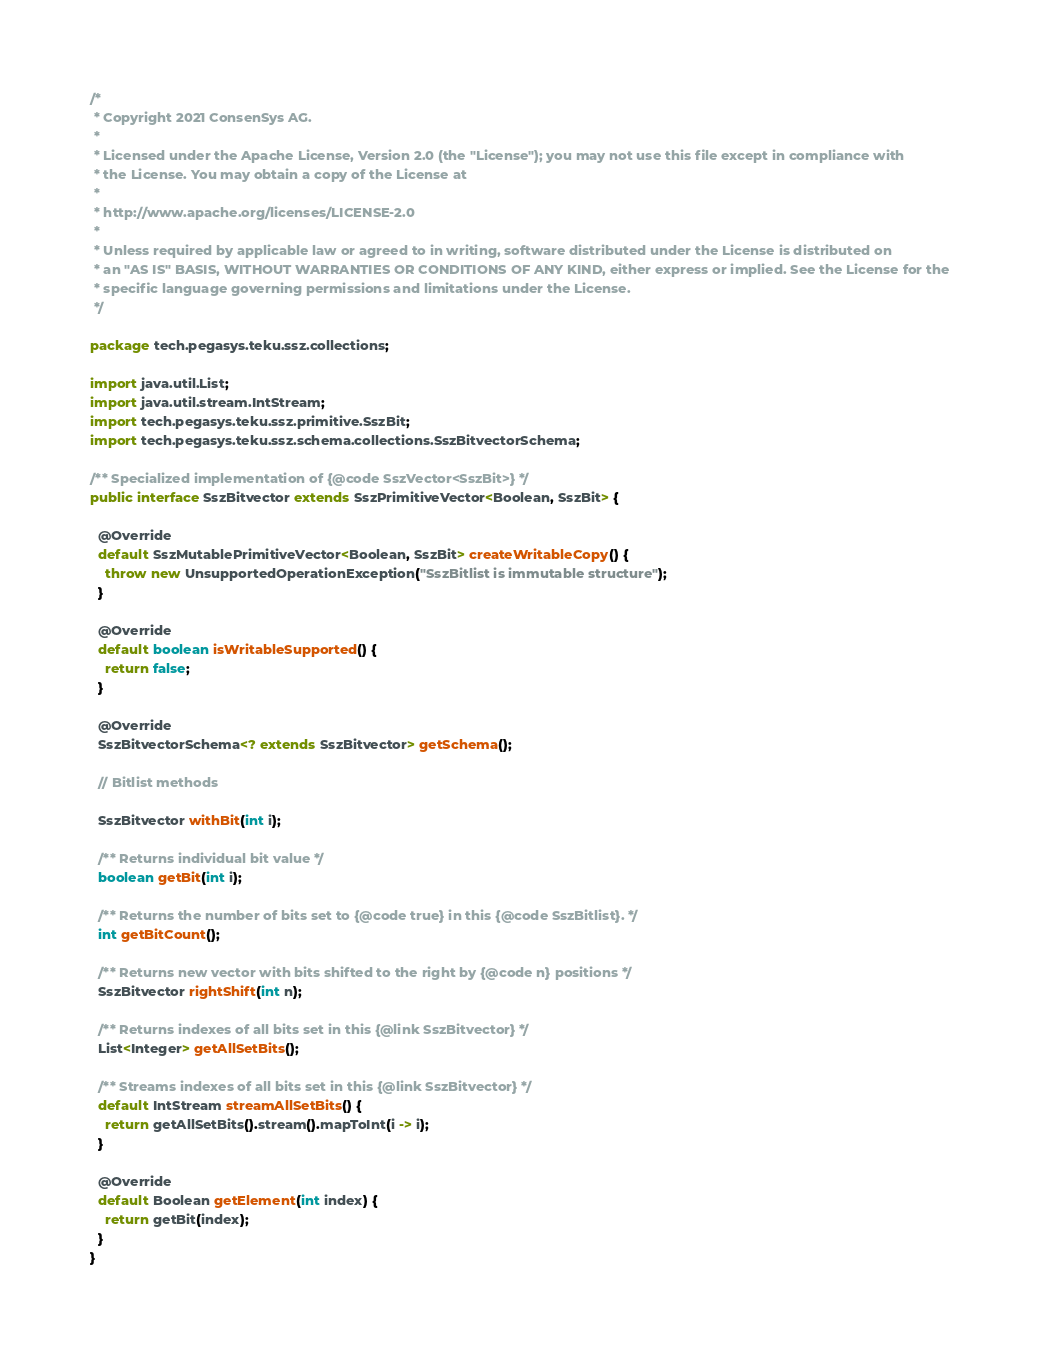<code> <loc_0><loc_0><loc_500><loc_500><_Java_>/*
 * Copyright 2021 ConsenSys AG.
 *
 * Licensed under the Apache License, Version 2.0 (the "License"); you may not use this file except in compliance with
 * the License. You may obtain a copy of the License at
 *
 * http://www.apache.org/licenses/LICENSE-2.0
 *
 * Unless required by applicable law or agreed to in writing, software distributed under the License is distributed on
 * an "AS IS" BASIS, WITHOUT WARRANTIES OR CONDITIONS OF ANY KIND, either express or implied. See the License for the
 * specific language governing permissions and limitations under the License.
 */

package tech.pegasys.teku.ssz.collections;

import java.util.List;
import java.util.stream.IntStream;
import tech.pegasys.teku.ssz.primitive.SszBit;
import tech.pegasys.teku.ssz.schema.collections.SszBitvectorSchema;

/** Specialized implementation of {@code SszVector<SszBit>} */
public interface SszBitvector extends SszPrimitiveVector<Boolean, SszBit> {

  @Override
  default SszMutablePrimitiveVector<Boolean, SszBit> createWritableCopy() {
    throw new UnsupportedOperationException("SszBitlist is immutable structure");
  }

  @Override
  default boolean isWritableSupported() {
    return false;
  }

  @Override
  SszBitvectorSchema<? extends SszBitvector> getSchema();

  // Bitlist methods

  SszBitvector withBit(int i);

  /** Returns individual bit value */
  boolean getBit(int i);

  /** Returns the number of bits set to {@code true} in this {@code SszBitlist}. */
  int getBitCount();

  /** Returns new vector with bits shifted to the right by {@code n} positions */
  SszBitvector rightShift(int n);

  /** Returns indexes of all bits set in this {@link SszBitvector} */
  List<Integer> getAllSetBits();

  /** Streams indexes of all bits set in this {@link SszBitvector} */
  default IntStream streamAllSetBits() {
    return getAllSetBits().stream().mapToInt(i -> i);
  }

  @Override
  default Boolean getElement(int index) {
    return getBit(index);
  }
}
</code> 